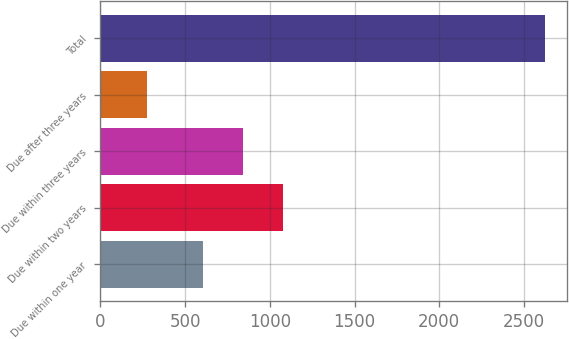<chart> <loc_0><loc_0><loc_500><loc_500><bar_chart><fcel>Due within one year<fcel>Due within two years<fcel>Due within three years<fcel>Due after three years<fcel>Total<nl><fcel>607.2<fcel>1076.46<fcel>841.83<fcel>275.3<fcel>2621.6<nl></chart> 